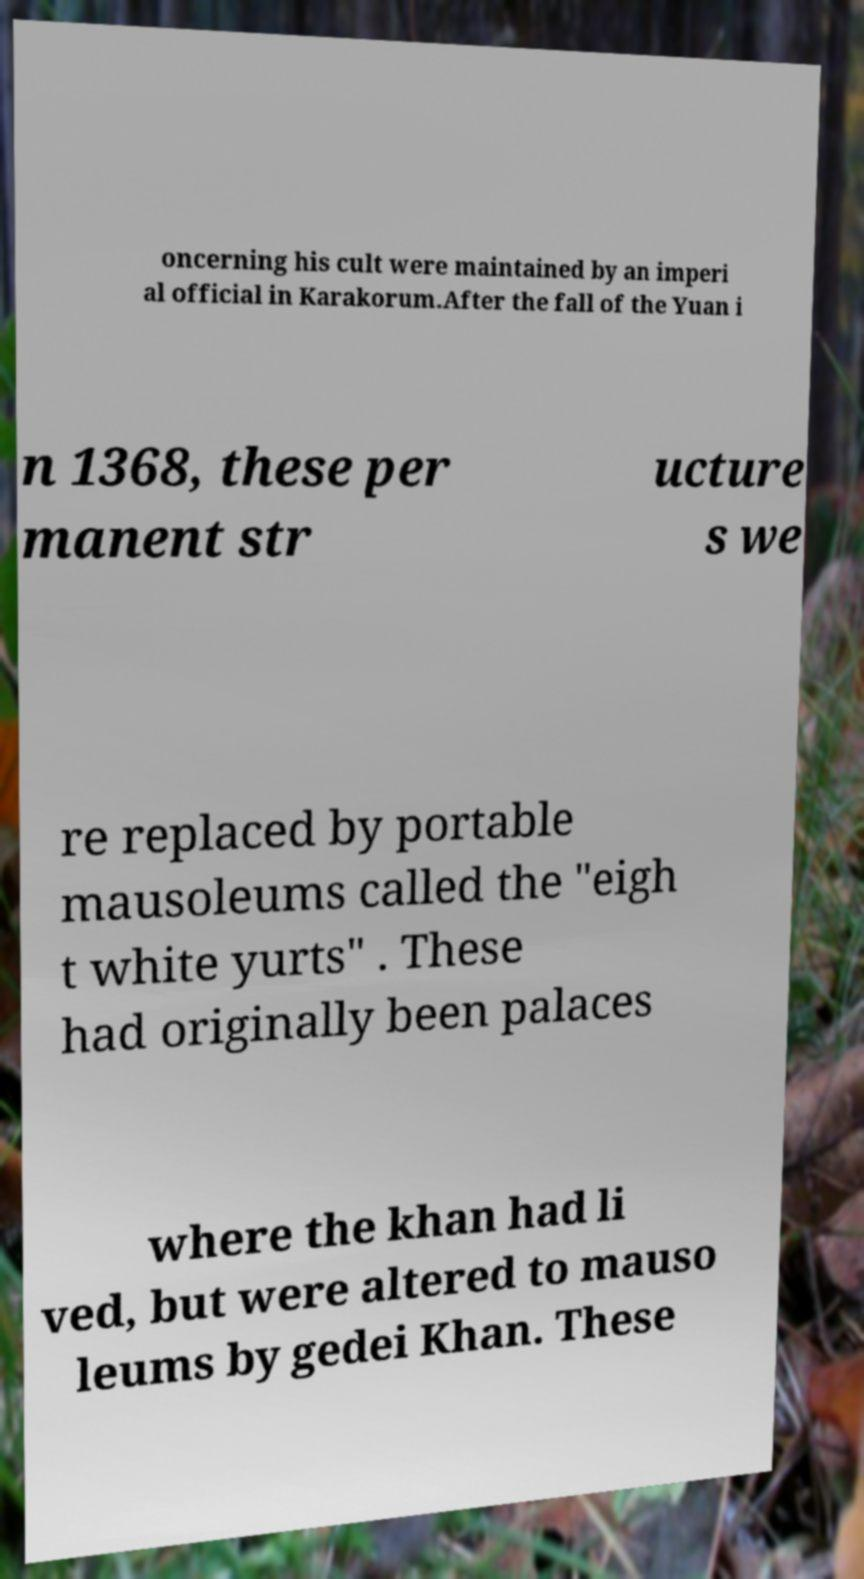There's text embedded in this image that I need extracted. Can you transcribe it verbatim? oncerning his cult were maintained by an imperi al official in Karakorum.After the fall of the Yuan i n 1368, these per manent str ucture s we re replaced by portable mausoleums called the "eigh t white yurts" . These had originally been palaces where the khan had li ved, but were altered to mauso leums by gedei Khan. These 